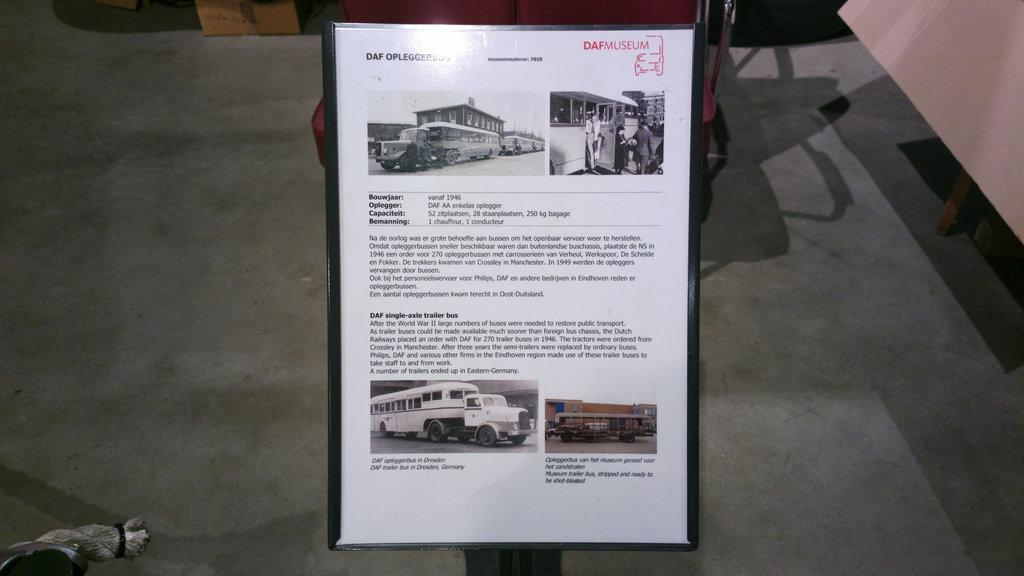What is present on the pad in the image? There is a poster on the pad in the image. What type of information does the poster contain? The poster contains information about vehicles. What other object can be seen in the image related to displaying information? There is a notice board in the image. Is there any indication of an object's presence through its shadow in the image? Yes, there is a shadow of an object on the floor in the image. What type of appliance is being used for a hobby in the image? There is no appliance or hobby-related activity present in the image. What type of sport is being played in the image? There is no sport, including volleyball, being played in the image. 